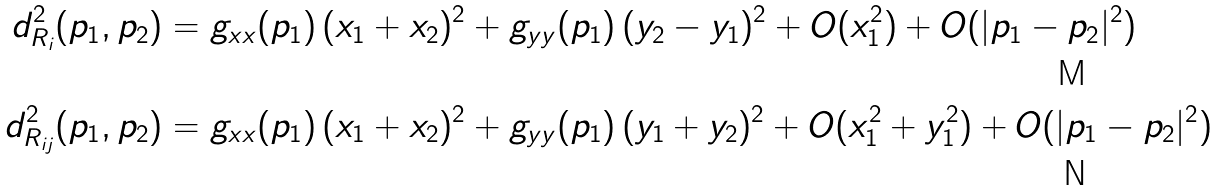<formula> <loc_0><loc_0><loc_500><loc_500>d ^ { 2 } _ { R _ { i } } ( p _ { 1 } , p _ { 2 } ) & = g _ { x x } ( p _ { 1 } ) \, ( x _ { 1 } + x _ { 2 } ) ^ { 2 } + g _ { y y } ( p _ { 1 } ) \, ( y _ { 2 } - y _ { 1 } ) ^ { 2 } + O ( x _ { 1 } ^ { 2 } ) + O ( | p _ { 1 } - p _ { 2 } | ^ { 2 } ) \\ d ^ { 2 } _ { R _ { i j } } ( p _ { 1 } , p _ { 2 } ) & = g _ { x x } ( p _ { 1 } ) \, ( x _ { 1 } + x _ { 2 } ) ^ { 2 } + g _ { y y } ( p _ { 1 } ) \, ( y _ { 1 } + y _ { 2 } ) ^ { 2 } + O ( x _ { 1 } ^ { 2 } + y _ { 1 } ^ { 2 } ) + O ( | p _ { 1 } - p _ { 2 } | ^ { 2 } )</formula> 